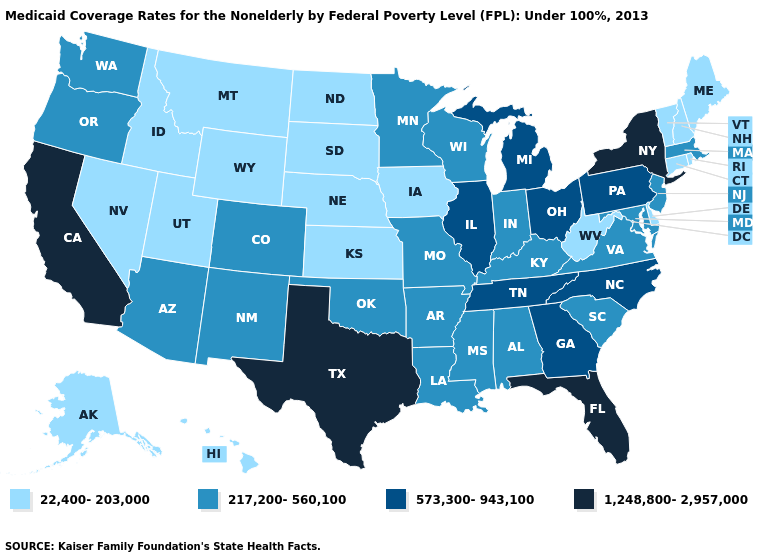What is the value of Indiana?
Short answer required. 217,200-560,100. Name the states that have a value in the range 1,248,800-2,957,000?
Write a very short answer. California, Florida, New York, Texas. Name the states that have a value in the range 573,300-943,100?
Short answer required. Georgia, Illinois, Michigan, North Carolina, Ohio, Pennsylvania, Tennessee. Does the map have missing data?
Keep it brief. No. Does Florida have a higher value than California?
Write a very short answer. No. Does Kansas have the lowest value in the USA?
Be succinct. Yes. Does the map have missing data?
Be succinct. No. What is the value of Idaho?
Write a very short answer. 22,400-203,000. Does Washington have the same value as Louisiana?
Keep it brief. Yes. What is the value of Mississippi?
Short answer required. 217,200-560,100. Among the states that border New Hampshire , does Massachusetts have the lowest value?
Write a very short answer. No. Does Kansas have the highest value in the MidWest?
Be succinct. No. Name the states that have a value in the range 217,200-560,100?
Answer briefly. Alabama, Arizona, Arkansas, Colorado, Indiana, Kentucky, Louisiana, Maryland, Massachusetts, Minnesota, Mississippi, Missouri, New Jersey, New Mexico, Oklahoma, Oregon, South Carolina, Virginia, Washington, Wisconsin. Does the first symbol in the legend represent the smallest category?
Keep it brief. Yes. Among the states that border Delaware , which have the highest value?
Answer briefly. Pennsylvania. 